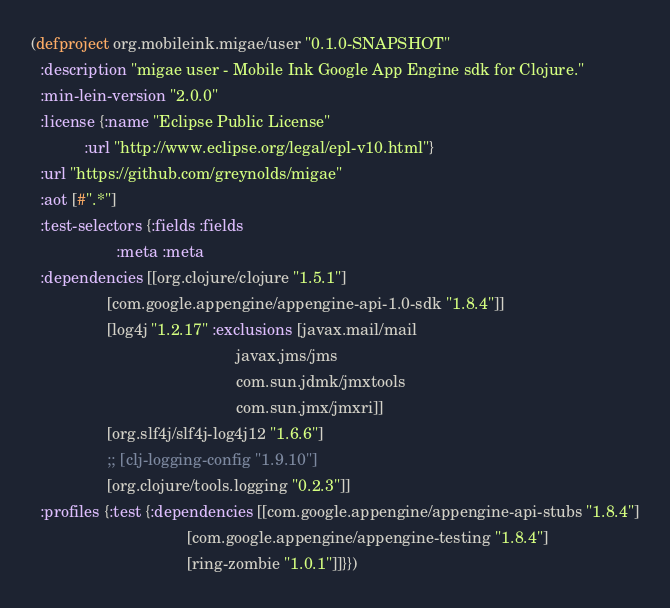Convert code to text. <code><loc_0><loc_0><loc_500><loc_500><_Clojure_>(defproject org.mobileink.migae/user "0.1.0-SNAPSHOT"
  :description "migae user - Mobile Ink Google App Engine sdk for Clojure."
  :min-lein-version "2.0.0"
  :license {:name "Eclipse Public License"
            :url "http://www.eclipse.org/legal/epl-v10.html"}
  :url "https://github.com/greynolds/migae"
  :aot [#".*"]
  :test-selectors {:fields :fields
                   :meta :meta
  :dependencies [[org.clojure/clojure "1.5.1"]
                 [com.google.appengine/appengine-api-1.0-sdk "1.8.4"]]
                 [log4j "1.2.17" :exclusions [javax.mail/mail
                                              javax.jms/jms
                                              com.sun.jdmk/jmxtools
                                              com.sun.jmx/jmxri]]
                 [org.slf4j/slf4j-log4j12 "1.6.6"]
                 ;; [clj-logging-config "1.9.10"]
                 [org.clojure/tools.logging "0.2.3"]]
  :profiles {:test {:dependencies [[com.google.appengine/appengine-api-stubs "1.8.4"]
                                   [com.google.appengine/appengine-testing "1.8.4"]
                                   [ring-zombie "1.0.1"]]}})



</code> 